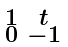<formula> <loc_0><loc_0><loc_500><loc_500>\begin{smallmatrix} 1 & t \\ 0 & - 1 \end{smallmatrix}</formula> 